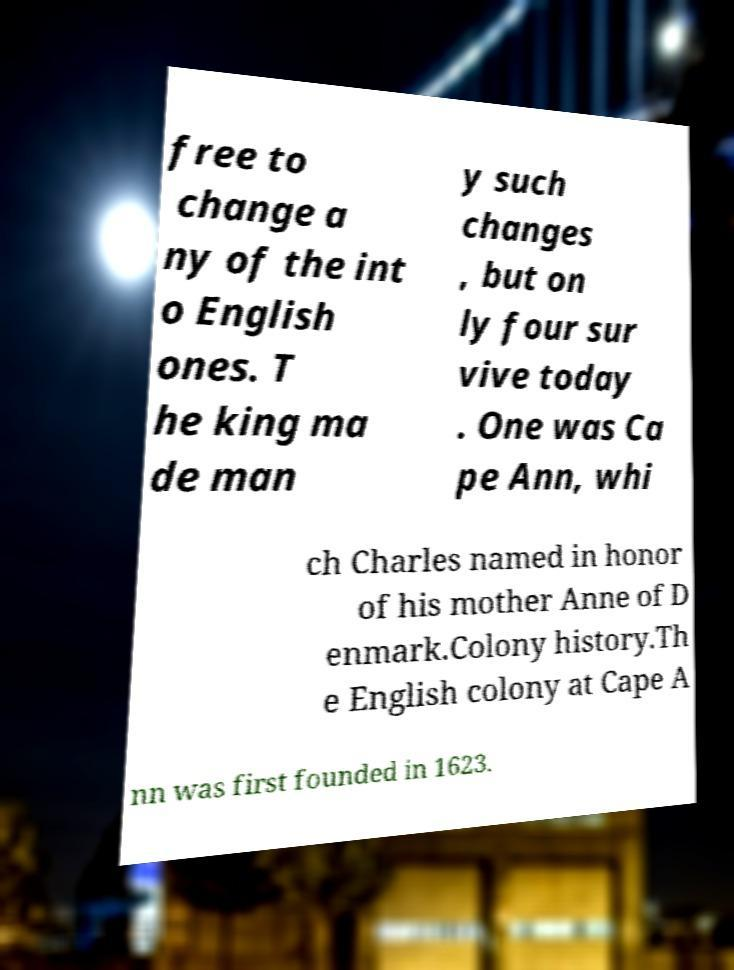Can you read and provide the text displayed in the image?This photo seems to have some interesting text. Can you extract and type it out for me? free to change a ny of the int o English ones. T he king ma de man y such changes , but on ly four sur vive today . One was Ca pe Ann, whi ch Charles named in honor of his mother Anne of D enmark.Colony history.Th e English colony at Cape A nn was first founded in 1623. 